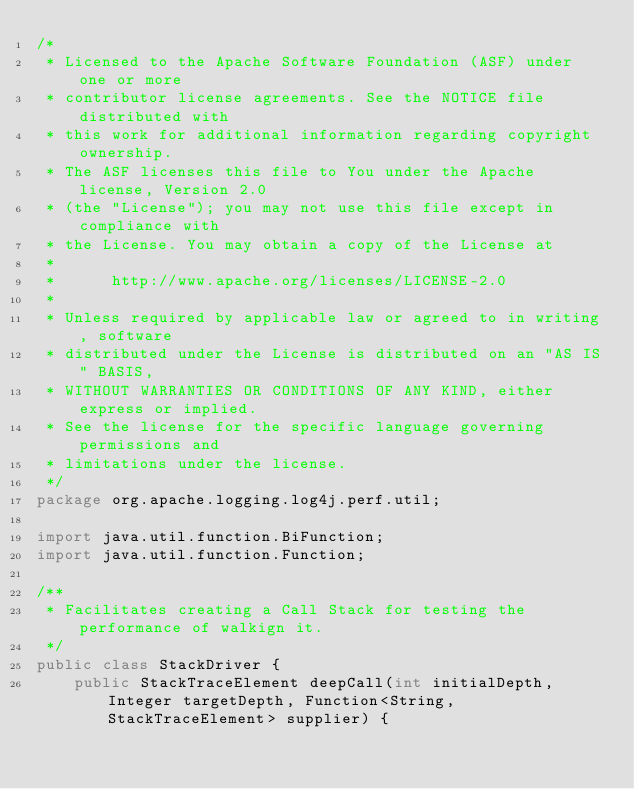Convert code to text. <code><loc_0><loc_0><loc_500><loc_500><_Java_>/*
 * Licensed to the Apache Software Foundation (ASF) under one or more
 * contributor license agreements. See the NOTICE file distributed with
 * this work for additional information regarding copyright ownership.
 * The ASF licenses this file to You under the Apache license, Version 2.0
 * (the "License"); you may not use this file except in compliance with
 * the License. You may obtain a copy of the License at
 *
 *      http://www.apache.org/licenses/LICENSE-2.0
 *
 * Unless required by applicable law or agreed to in writing, software
 * distributed under the License is distributed on an "AS IS" BASIS,
 * WITHOUT WARRANTIES OR CONDITIONS OF ANY KIND, either express or implied.
 * See the license for the specific language governing permissions and
 * limitations under the license.
 */
package org.apache.logging.log4j.perf.util;

import java.util.function.BiFunction;
import java.util.function.Function;

/**
 * Facilitates creating a Call Stack for testing the performance of walkign it.
 */
public class StackDriver {
    public StackTraceElement deepCall(int initialDepth, Integer targetDepth, Function<String, StackTraceElement> supplier) {</code> 